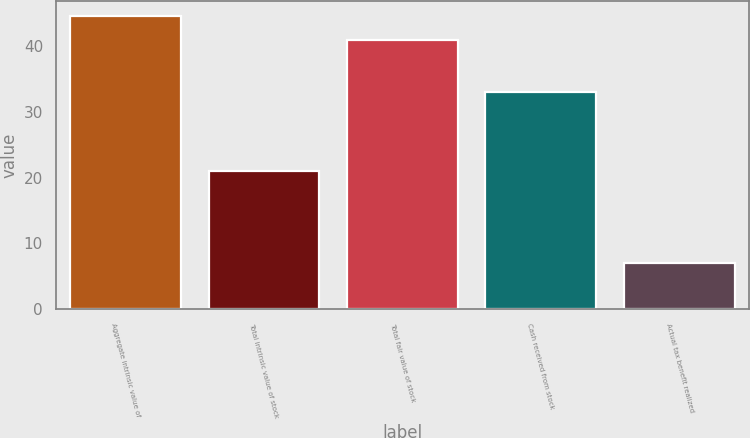Convert chart to OTSL. <chart><loc_0><loc_0><loc_500><loc_500><bar_chart><fcel>Aggregate intrinsic value of<fcel>Total intrinsic value of stock<fcel>Total fair value of stock<fcel>Cash received from stock<fcel>Actual tax benefit realized<nl><fcel>44.6<fcel>21<fcel>41<fcel>33<fcel>7<nl></chart> 